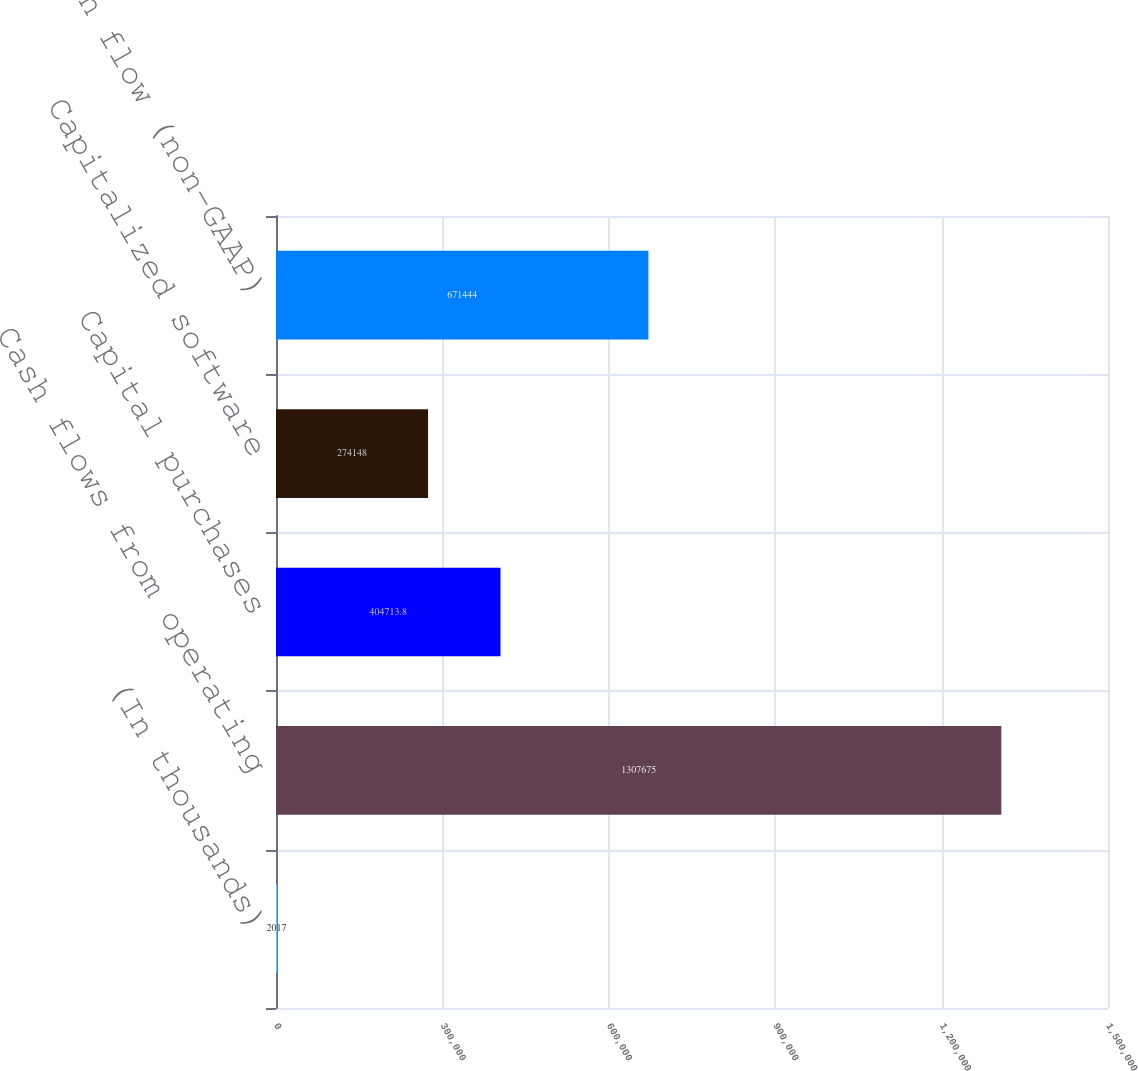<chart> <loc_0><loc_0><loc_500><loc_500><bar_chart><fcel>(In thousands)<fcel>Cash flows from operating<fcel>Capital purchases<fcel>Capitalized software<fcel>Free cash flow (non-GAAP)<nl><fcel>2017<fcel>1.30768e+06<fcel>404714<fcel>274148<fcel>671444<nl></chart> 